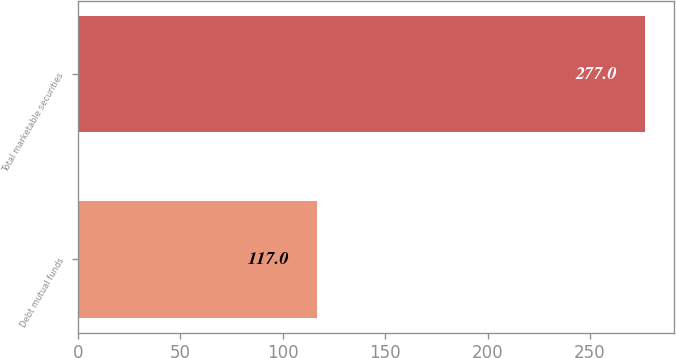Convert chart to OTSL. <chart><loc_0><loc_0><loc_500><loc_500><bar_chart><fcel>Debt mutual funds<fcel>Total marketable securities<nl><fcel>117<fcel>277<nl></chart> 